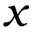Convert formula to latex. <formula><loc_0><loc_0><loc_500><loc_500>x</formula> 